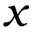Convert formula to latex. <formula><loc_0><loc_0><loc_500><loc_500>x</formula> 